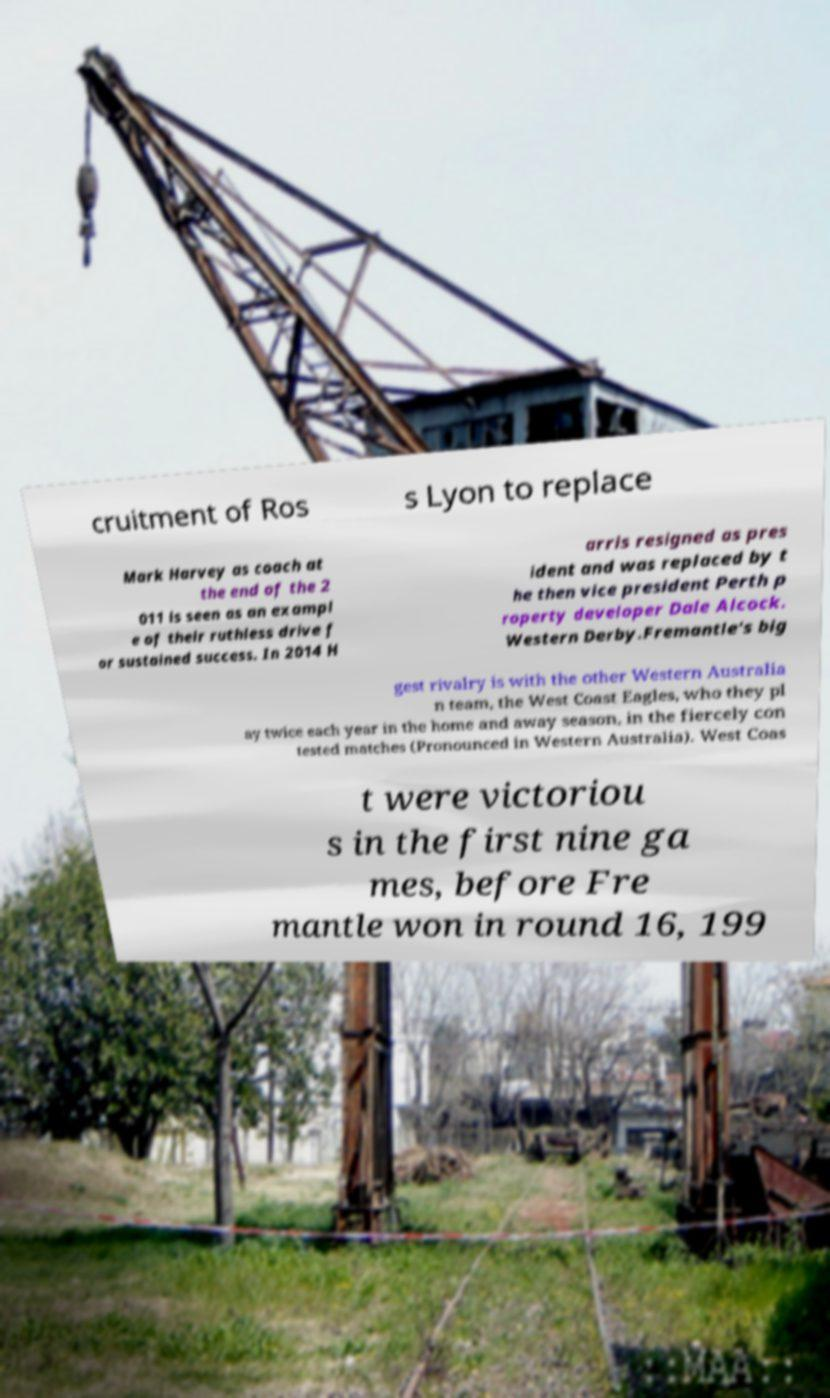Can you read and provide the text displayed in the image?This photo seems to have some interesting text. Can you extract and type it out for me? cruitment of Ros s Lyon to replace Mark Harvey as coach at the end of the 2 011 is seen as an exampl e of their ruthless drive f or sustained success. In 2014 H arris resigned as pres ident and was replaced by t he then vice president Perth p roperty developer Dale Alcock. Western Derby.Fremantle's big gest rivalry is with the other Western Australia n team, the West Coast Eagles, who they pl ay twice each year in the home and away season, in the fiercely con tested matches (Pronounced in Western Australia). West Coas t were victoriou s in the first nine ga mes, before Fre mantle won in round 16, 199 